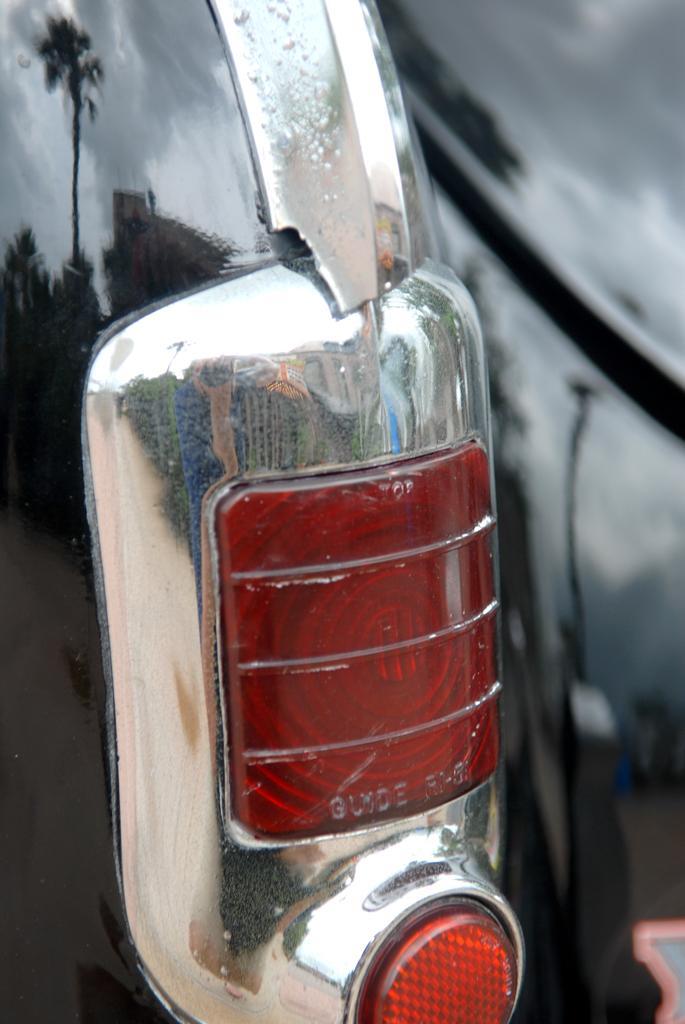Please provide a concise description of this image. The picture consists of a vehicle, we can see the tail light of the vehicle. 